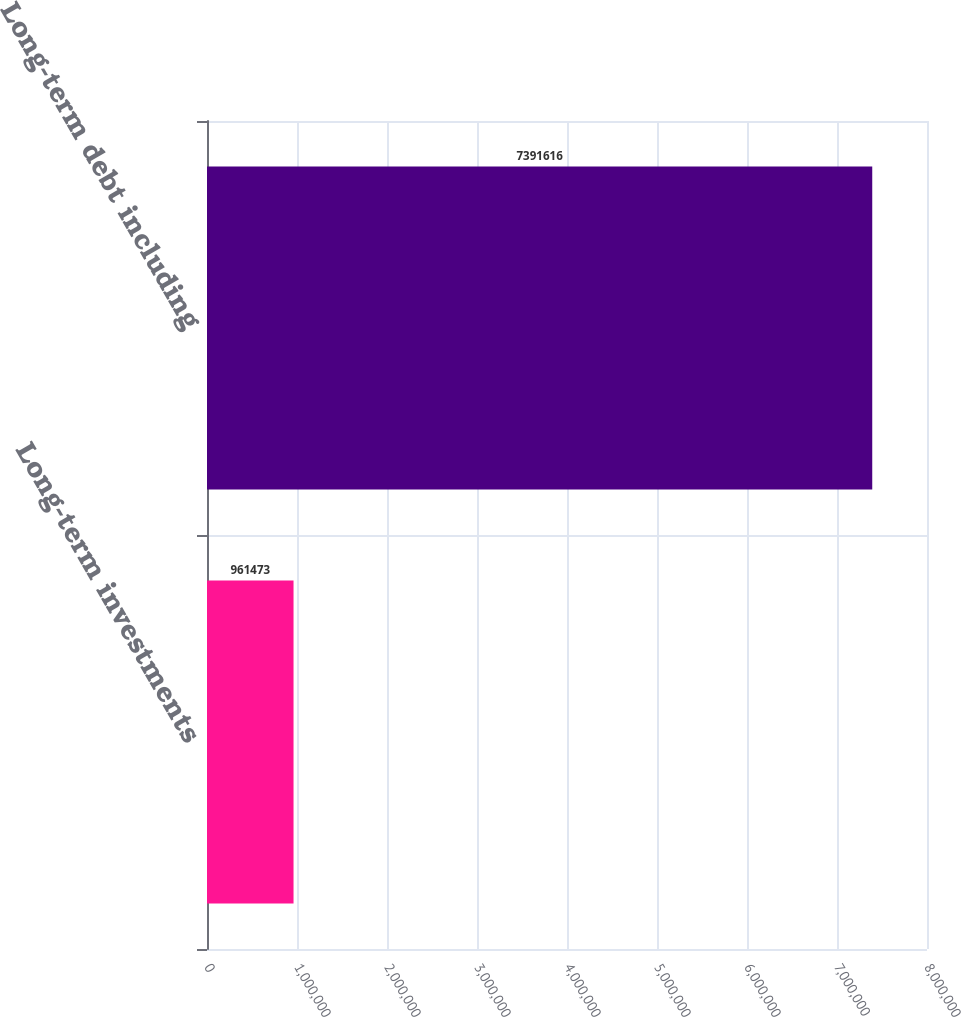Convert chart. <chart><loc_0><loc_0><loc_500><loc_500><bar_chart><fcel>Long-term investments<fcel>Long-term debt including<nl><fcel>961473<fcel>7.39162e+06<nl></chart> 